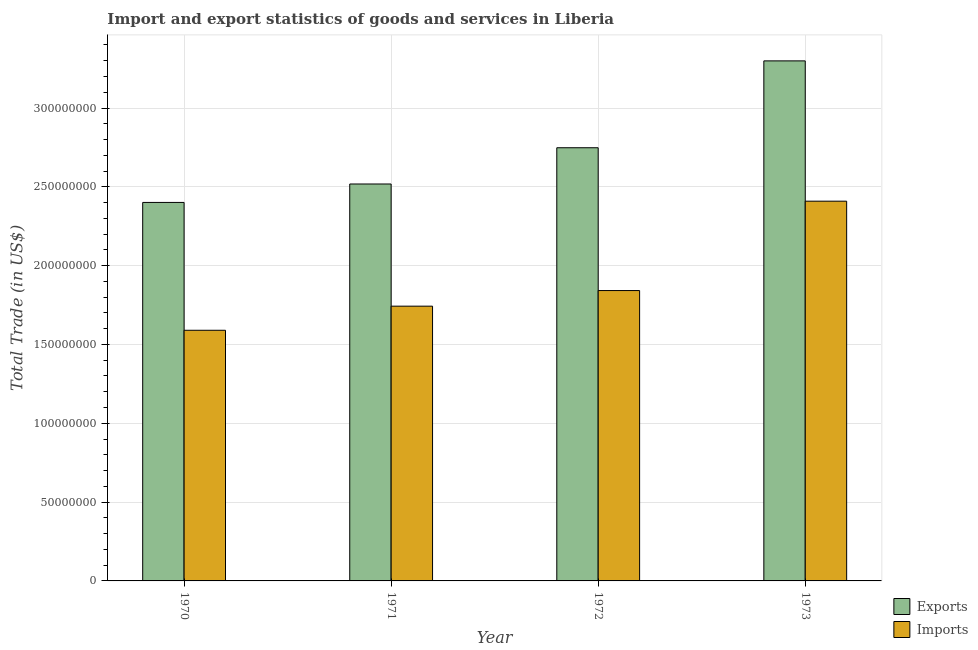How many different coloured bars are there?
Provide a short and direct response. 2. How many groups of bars are there?
Offer a terse response. 4. How many bars are there on the 3rd tick from the left?
Give a very brief answer. 2. How many bars are there on the 1st tick from the right?
Your answer should be compact. 2. What is the imports of goods and services in 1973?
Provide a succinct answer. 2.41e+08. Across all years, what is the maximum export of goods and services?
Your answer should be compact. 3.30e+08. Across all years, what is the minimum export of goods and services?
Keep it short and to the point. 2.40e+08. What is the total export of goods and services in the graph?
Keep it short and to the point. 1.10e+09. What is the difference between the export of goods and services in 1972 and that in 1973?
Keep it short and to the point. -5.51e+07. What is the difference between the export of goods and services in 1971 and the imports of goods and services in 1970?
Offer a very short reply. 1.17e+07. What is the average imports of goods and services per year?
Offer a terse response. 1.90e+08. In how many years, is the imports of goods and services greater than 300000000 US$?
Ensure brevity in your answer.  0. What is the ratio of the export of goods and services in 1970 to that in 1971?
Keep it short and to the point. 0.95. Is the difference between the export of goods and services in 1970 and 1971 greater than the difference between the imports of goods and services in 1970 and 1971?
Provide a succinct answer. No. What is the difference between the highest and the second highest export of goods and services?
Your response must be concise. 5.51e+07. What is the difference between the highest and the lowest imports of goods and services?
Give a very brief answer. 8.19e+07. In how many years, is the export of goods and services greater than the average export of goods and services taken over all years?
Provide a succinct answer. 2. What does the 1st bar from the left in 1972 represents?
Offer a very short reply. Exports. What does the 1st bar from the right in 1970 represents?
Ensure brevity in your answer.  Imports. How many bars are there?
Your answer should be very brief. 8. What is the difference between two consecutive major ticks on the Y-axis?
Keep it short and to the point. 5.00e+07. Are the values on the major ticks of Y-axis written in scientific E-notation?
Make the answer very short. No. Does the graph contain grids?
Provide a short and direct response. Yes. Where does the legend appear in the graph?
Keep it short and to the point. Bottom right. How are the legend labels stacked?
Give a very brief answer. Vertical. What is the title of the graph?
Give a very brief answer. Import and export statistics of goods and services in Liberia. Does "Under-5(female)" appear as one of the legend labels in the graph?
Your answer should be compact. No. What is the label or title of the X-axis?
Give a very brief answer. Year. What is the label or title of the Y-axis?
Your answer should be very brief. Total Trade (in US$). What is the Total Trade (in US$) in Exports in 1970?
Your answer should be compact. 2.40e+08. What is the Total Trade (in US$) in Imports in 1970?
Ensure brevity in your answer.  1.59e+08. What is the Total Trade (in US$) in Exports in 1971?
Offer a terse response. 2.52e+08. What is the Total Trade (in US$) in Imports in 1971?
Make the answer very short. 1.74e+08. What is the Total Trade (in US$) in Exports in 1972?
Give a very brief answer. 2.75e+08. What is the Total Trade (in US$) in Imports in 1972?
Provide a succinct answer. 1.84e+08. What is the Total Trade (in US$) of Exports in 1973?
Provide a succinct answer. 3.30e+08. What is the Total Trade (in US$) in Imports in 1973?
Provide a succinct answer. 2.41e+08. Across all years, what is the maximum Total Trade (in US$) in Exports?
Make the answer very short. 3.30e+08. Across all years, what is the maximum Total Trade (in US$) of Imports?
Your response must be concise. 2.41e+08. Across all years, what is the minimum Total Trade (in US$) in Exports?
Offer a terse response. 2.40e+08. Across all years, what is the minimum Total Trade (in US$) in Imports?
Offer a terse response. 1.59e+08. What is the total Total Trade (in US$) of Exports in the graph?
Keep it short and to the point. 1.10e+09. What is the total Total Trade (in US$) of Imports in the graph?
Provide a short and direct response. 7.58e+08. What is the difference between the Total Trade (in US$) in Exports in 1970 and that in 1971?
Make the answer very short. -1.17e+07. What is the difference between the Total Trade (in US$) of Imports in 1970 and that in 1971?
Offer a terse response. -1.53e+07. What is the difference between the Total Trade (in US$) in Exports in 1970 and that in 1972?
Keep it short and to the point. -3.47e+07. What is the difference between the Total Trade (in US$) of Imports in 1970 and that in 1972?
Your answer should be compact. -2.52e+07. What is the difference between the Total Trade (in US$) in Exports in 1970 and that in 1973?
Offer a very short reply. -8.98e+07. What is the difference between the Total Trade (in US$) of Imports in 1970 and that in 1973?
Your response must be concise. -8.19e+07. What is the difference between the Total Trade (in US$) of Exports in 1971 and that in 1972?
Make the answer very short. -2.30e+07. What is the difference between the Total Trade (in US$) of Imports in 1971 and that in 1972?
Offer a terse response. -9.90e+06. What is the difference between the Total Trade (in US$) of Exports in 1971 and that in 1973?
Your answer should be compact. -7.81e+07. What is the difference between the Total Trade (in US$) in Imports in 1971 and that in 1973?
Keep it short and to the point. -6.66e+07. What is the difference between the Total Trade (in US$) of Exports in 1972 and that in 1973?
Ensure brevity in your answer.  -5.51e+07. What is the difference between the Total Trade (in US$) in Imports in 1972 and that in 1973?
Keep it short and to the point. -5.67e+07. What is the difference between the Total Trade (in US$) of Exports in 1970 and the Total Trade (in US$) of Imports in 1971?
Your answer should be very brief. 6.58e+07. What is the difference between the Total Trade (in US$) of Exports in 1970 and the Total Trade (in US$) of Imports in 1972?
Provide a succinct answer. 5.59e+07. What is the difference between the Total Trade (in US$) of Exports in 1970 and the Total Trade (in US$) of Imports in 1973?
Offer a terse response. -8.00e+05. What is the difference between the Total Trade (in US$) in Exports in 1971 and the Total Trade (in US$) in Imports in 1972?
Your answer should be very brief. 6.76e+07. What is the difference between the Total Trade (in US$) in Exports in 1971 and the Total Trade (in US$) in Imports in 1973?
Ensure brevity in your answer.  1.09e+07. What is the difference between the Total Trade (in US$) in Exports in 1972 and the Total Trade (in US$) in Imports in 1973?
Give a very brief answer. 3.39e+07. What is the average Total Trade (in US$) in Exports per year?
Offer a very short reply. 2.74e+08. What is the average Total Trade (in US$) in Imports per year?
Ensure brevity in your answer.  1.90e+08. In the year 1970, what is the difference between the Total Trade (in US$) in Exports and Total Trade (in US$) in Imports?
Give a very brief answer. 8.11e+07. In the year 1971, what is the difference between the Total Trade (in US$) in Exports and Total Trade (in US$) in Imports?
Make the answer very short. 7.75e+07. In the year 1972, what is the difference between the Total Trade (in US$) in Exports and Total Trade (in US$) in Imports?
Offer a terse response. 9.06e+07. In the year 1973, what is the difference between the Total Trade (in US$) of Exports and Total Trade (in US$) of Imports?
Your answer should be very brief. 8.90e+07. What is the ratio of the Total Trade (in US$) in Exports in 1970 to that in 1971?
Make the answer very short. 0.95. What is the ratio of the Total Trade (in US$) of Imports in 1970 to that in 1971?
Offer a terse response. 0.91. What is the ratio of the Total Trade (in US$) in Exports in 1970 to that in 1972?
Provide a short and direct response. 0.87. What is the ratio of the Total Trade (in US$) in Imports in 1970 to that in 1972?
Keep it short and to the point. 0.86. What is the ratio of the Total Trade (in US$) in Exports in 1970 to that in 1973?
Your response must be concise. 0.73. What is the ratio of the Total Trade (in US$) in Imports in 1970 to that in 1973?
Keep it short and to the point. 0.66. What is the ratio of the Total Trade (in US$) in Exports in 1971 to that in 1972?
Ensure brevity in your answer.  0.92. What is the ratio of the Total Trade (in US$) of Imports in 1971 to that in 1972?
Your response must be concise. 0.95. What is the ratio of the Total Trade (in US$) of Exports in 1971 to that in 1973?
Give a very brief answer. 0.76. What is the ratio of the Total Trade (in US$) in Imports in 1971 to that in 1973?
Offer a terse response. 0.72. What is the ratio of the Total Trade (in US$) of Exports in 1972 to that in 1973?
Your answer should be very brief. 0.83. What is the ratio of the Total Trade (in US$) in Imports in 1972 to that in 1973?
Ensure brevity in your answer.  0.76. What is the difference between the highest and the second highest Total Trade (in US$) in Exports?
Your answer should be compact. 5.51e+07. What is the difference between the highest and the second highest Total Trade (in US$) of Imports?
Offer a very short reply. 5.67e+07. What is the difference between the highest and the lowest Total Trade (in US$) in Exports?
Ensure brevity in your answer.  8.98e+07. What is the difference between the highest and the lowest Total Trade (in US$) of Imports?
Your answer should be very brief. 8.19e+07. 